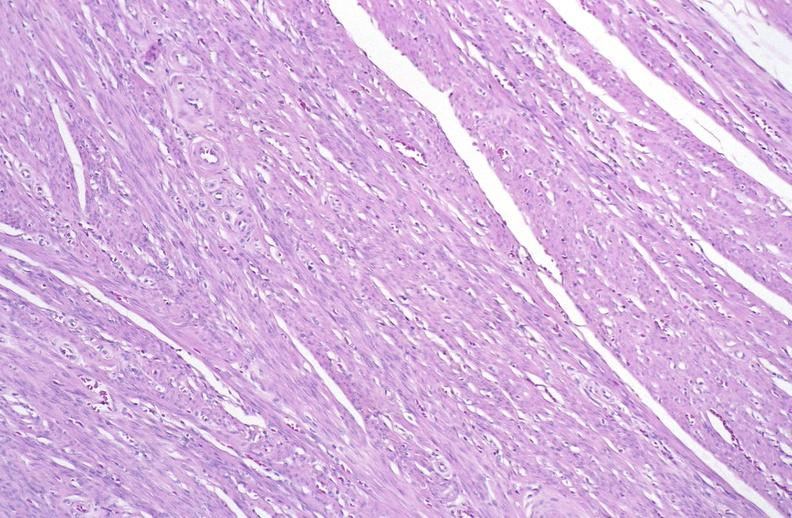does this image show normal uterus?
Answer the question using a single word or phrase. Yes 